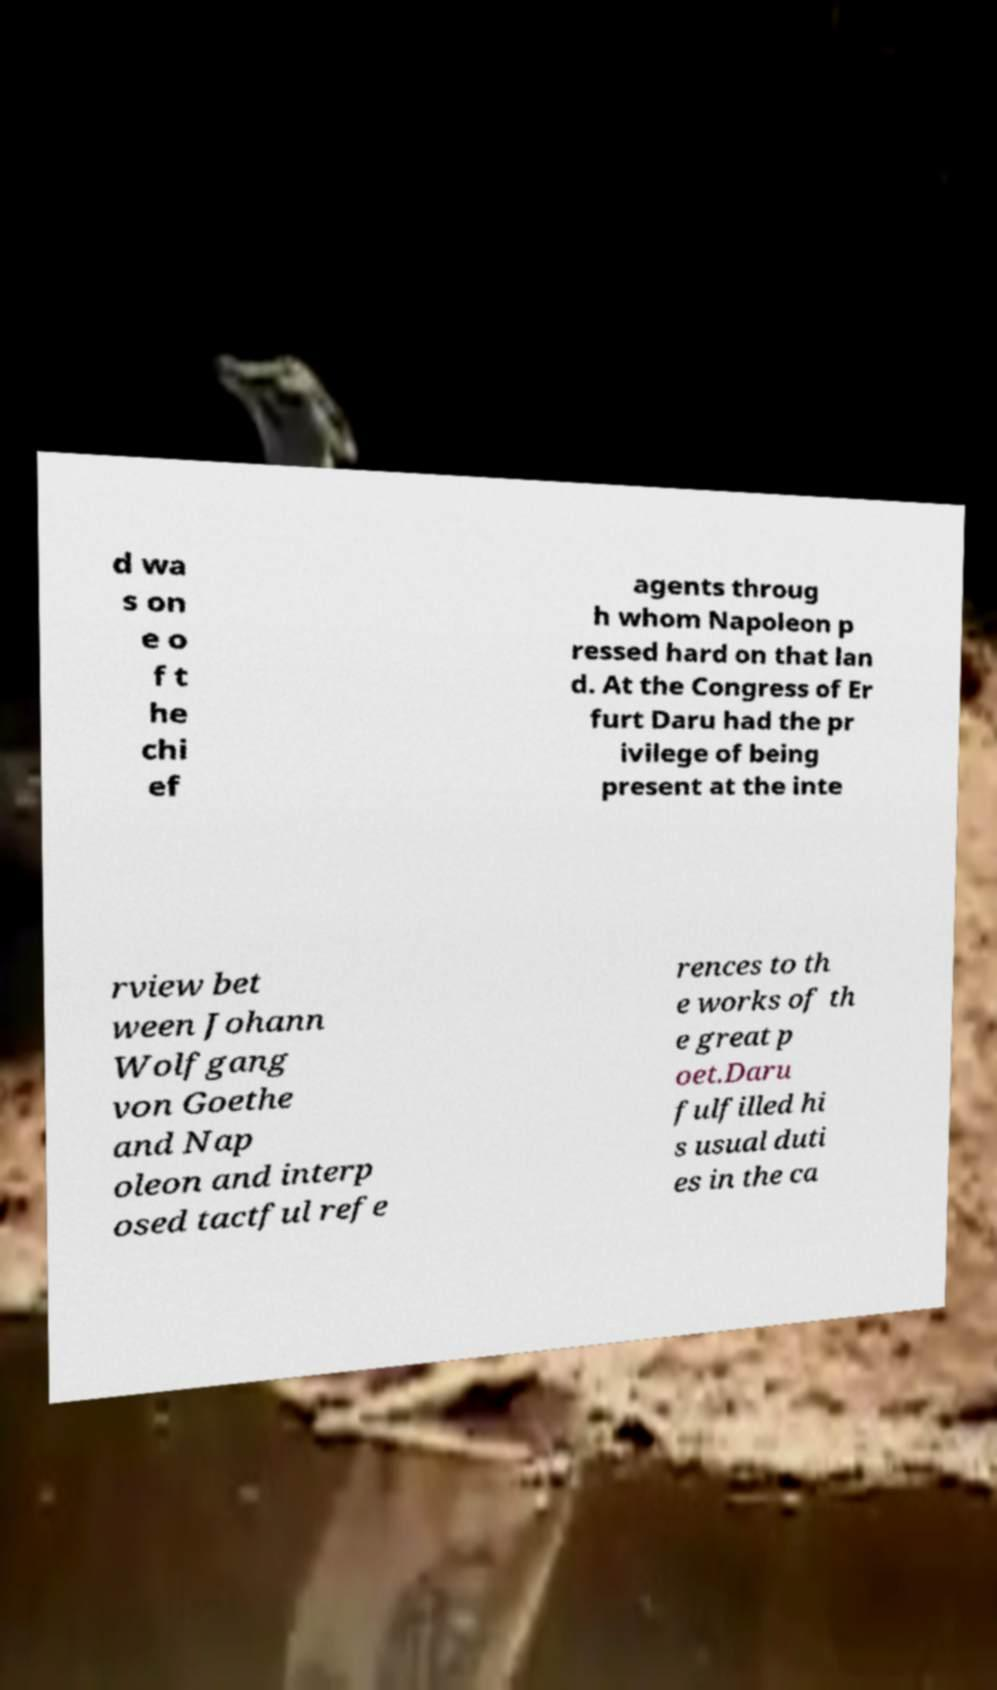Please read and relay the text visible in this image. What does it say? d wa s on e o f t he chi ef agents throug h whom Napoleon p ressed hard on that lan d. At the Congress of Er furt Daru had the pr ivilege of being present at the inte rview bet ween Johann Wolfgang von Goethe and Nap oleon and interp osed tactful refe rences to th e works of th e great p oet.Daru fulfilled hi s usual duti es in the ca 